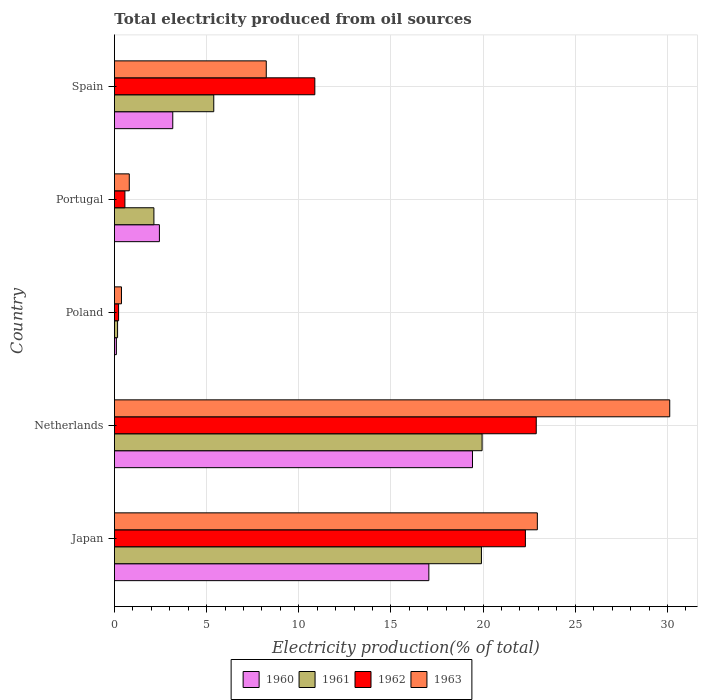How many groups of bars are there?
Your answer should be very brief. 5. Are the number of bars per tick equal to the number of legend labels?
Give a very brief answer. Yes. Are the number of bars on each tick of the Y-axis equal?
Offer a terse response. Yes. What is the label of the 3rd group of bars from the top?
Keep it short and to the point. Poland. In how many cases, is the number of bars for a given country not equal to the number of legend labels?
Your answer should be compact. 0. What is the total electricity produced in 1963 in Netherlands?
Your answer should be compact. 30.12. Across all countries, what is the maximum total electricity produced in 1962?
Offer a terse response. 22.88. Across all countries, what is the minimum total electricity produced in 1962?
Your answer should be very brief. 0.23. In which country was the total electricity produced in 1961 minimum?
Keep it short and to the point. Poland. What is the total total electricity produced in 1960 in the graph?
Your response must be concise. 42.19. What is the difference between the total electricity produced in 1963 in Japan and that in Portugal?
Keep it short and to the point. 22.14. What is the difference between the total electricity produced in 1962 in Japan and the total electricity produced in 1961 in Portugal?
Your response must be concise. 20.15. What is the average total electricity produced in 1961 per country?
Your answer should be very brief. 9.51. What is the difference between the total electricity produced in 1960 and total electricity produced in 1963 in Portugal?
Your response must be concise. 1.63. What is the ratio of the total electricity produced in 1960 in Netherlands to that in Spain?
Provide a succinct answer. 6.14. Is the total electricity produced in 1960 in Japan less than that in Poland?
Provide a succinct answer. No. What is the difference between the highest and the second highest total electricity produced in 1960?
Give a very brief answer. 2.37. What is the difference between the highest and the lowest total electricity produced in 1963?
Your answer should be compact. 29.74. Is the sum of the total electricity produced in 1962 in Japan and Netherlands greater than the maximum total electricity produced in 1963 across all countries?
Your answer should be compact. Yes. Is it the case that in every country, the sum of the total electricity produced in 1963 and total electricity produced in 1961 is greater than the sum of total electricity produced in 1960 and total electricity produced in 1962?
Your answer should be compact. No. What does the 2nd bar from the top in Poland represents?
Offer a terse response. 1962. What does the 2nd bar from the bottom in Portugal represents?
Offer a very short reply. 1961. Is it the case that in every country, the sum of the total electricity produced in 1961 and total electricity produced in 1962 is greater than the total electricity produced in 1960?
Your answer should be compact. Yes. How many bars are there?
Give a very brief answer. 20. Are all the bars in the graph horizontal?
Your answer should be very brief. Yes. How many countries are there in the graph?
Make the answer very short. 5. Are the values on the major ticks of X-axis written in scientific E-notation?
Offer a very short reply. No. Does the graph contain any zero values?
Make the answer very short. No. Does the graph contain grids?
Your response must be concise. Yes. Where does the legend appear in the graph?
Offer a terse response. Bottom center. What is the title of the graph?
Offer a terse response. Total electricity produced from oil sources. Does "1990" appear as one of the legend labels in the graph?
Keep it short and to the point. No. What is the Electricity production(% of total) of 1960 in Japan?
Ensure brevity in your answer.  17.06. What is the Electricity production(% of total) of 1961 in Japan?
Offer a very short reply. 19.91. What is the Electricity production(% of total) of 1962 in Japan?
Your response must be concise. 22.29. What is the Electricity production(% of total) in 1963 in Japan?
Give a very brief answer. 22.94. What is the Electricity production(% of total) in 1960 in Netherlands?
Your answer should be compact. 19.42. What is the Electricity production(% of total) of 1961 in Netherlands?
Give a very brief answer. 19.94. What is the Electricity production(% of total) of 1962 in Netherlands?
Offer a terse response. 22.88. What is the Electricity production(% of total) in 1963 in Netherlands?
Offer a terse response. 30.12. What is the Electricity production(% of total) in 1960 in Poland?
Your answer should be very brief. 0.11. What is the Electricity production(% of total) in 1961 in Poland?
Offer a terse response. 0.17. What is the Electricity production(% of total) of 1962 in Poland?
Give a very brief answer. 0.23. What is the Electricity production(% of total) of 1963 in Poland?
Offer a terse response. 0.38. What is the Electricity production(% of total) of 1960 in Portugal?
Your answer should be very brief. 2.44. What is the Electricity production(% of total) of 1961 in Portugal?
Offer a very short reply. 2.14. What is the Electricity production(% of total) of 1962 in Portugal?
Your response must be concise. 0.57. What is the Electricity production(% of total) in 1963 in Portugal?
Give a very brief answer. 0.81. What is the Electricity production(% of total) in 1960 in Spain?
Provide a succinct answer. 3.16. What is the Electricity production(% of total) in 1961 in Spain?
Make the answer very short. 5.39. What is the Electricity production(% of total) in 1962 in Spain?
Your answer should be compact. 10.87. What is the Electricity production(% of total) in 1963 in Spain?
Keep it short and to the point. 8.24. Across all countries, what is the maximum Electricity production(% of total) of 1960?
Provide a succinct answer. 19.42. Across all countries, what is the maximum Electricity production(% of total) in 1961?
Offer a terse response. 19.94. Across all countries, what is the maximum Electricity production(% of total) of 1962?
Your response must be concise. 22.88. Across all countries, what is the maximum Electricity production(% of total) of 1963?
Provide a succinct answer. 30.12. Across all countries, what is the minimum Electricity production(% of total) in 1960?
Make the answer very short. 0.11. Across all countries, what is the minimum Electricity production(% of total) in 1961?
Keep it short and to the point. 0.17. Across all countries, what is the minimum Electricity production(% of total) of 1962?
Give a very brief answer. 0.23. Across all countries, what is the minimum Electricity production(% of total) in 1963?
Make the answer very short. 0.38. What is the total Electricity production(% of total) of 1960 in the graph?
Your response must be concise. 42.19. What is the total Electricity production(% of total) of 1961 in the graph?
Make the answer very short. 47.55. What is the total Electricity production(% of total) of 1962 in the graph?
Provide a short and direct response. 56.84. What is the total Electricity production(% of total) of 1963 in the graph?
Make the answer very short. 62.49. What is the difference between the Electricity production(% of total) in 1960 in Japan and that in Netherlands?
Your answer should be very brief. -2.37. What is the difference between the Electricity production(% of total) of 1961 in Japan and that in Netherlands?
Your answer should be very brief. -0.04. What is the difference between the Electricity production(% of total) of 1962 in Japan and that in Netherlands?
Provide a short and direct response. -0.59. What is the difference between the Electricity production(% of total) in 1963 in Japan and that in Netherlands?
Your response must be concise. -7.18. What is the difference between the Electricity production(% of total) of 1960 in Japan and that in Poland?
Make the answer very short. 16.95. What is the difference between the Electricity production(% of total) in 1961 in Japan and that in Poland?
Ensure brevity in your answer.  19.74. What is the difference between the Electricity production(% of total) of 1962 in Japan and that in Poland?
Your answer should be very brief. 22.07. What is the difference between the Electricity production(% of total) in 1963 in Japan and that in Poland?
Your answer should be very brief. 22.56. What is the difference between the Electricity production(% of total) of 1960 in Japan and that in Portugal?
Your response must be concise. 14.62. What is the difference between the Electricity production(% of total) of 1961 in Japan and that in Portugal?
Your answer should be compact. 17.77. What is the difference between the Electricity production(% of total) of 1962 in Japan and that in Portugal?
Your answer should be very brief. 21.73. What is the difference between the Electricity production(% of total) of 1963 in Japan and that in Portugal?
Provide a succinct answer. 22.14. What is the difference between the Electricity production(% of total) in 1960 in Japan and that in Spain?
Keep it short and to the point. 13.89. What is the difference between the Electricity production(% of total) of 1961 in Japan and that in Spain?
Provide a short and direct response. 14.52. What is the difference between the Electricity production(% of total) of 1962 in Japan and that in Spain?
Make the answer very short. 11.42. What is the difference between the Electricity production(% of total) of 1963 in Japan and that in Spain?
Provide a succinct answer. 14.71. What is the difference between the Electricity production(% of total) of 1960 in Netherlands and that in Poland?
Ensure brevity in your answer.  19.32. What is the difference between the Electricity production(% of total) in 1961 in Netherlands and that in Poland?
Provide a succinct answer. 19.77. What is the difference between the Electricity production(% of total) in 1962 in Netherlands and that in Poland?
Keep it short and to the point. 22.66. What is the difference between the Electricity production(% of total) in 1963 in Netherlands and that in Poland?
Your response must be concise. 29.74. What is the difference between the Electricity production(% of total) of 1960 in Netherlands and that in Portugal?
Provide a succinct answer. 16.98. What is the difference between the Electricity production(% of total) in 1961 in Netherlands and that in Portugal?
Offer a very short reply. 17.8. What is the difference between the Electricity production(% of total) of 1962 in Netherlands and that in Portugal?
Offer a terse response. 22.31. What is the difference between the Electricity production(% of total) of 1963 in Netherlands and that in Portugal?
Provide a short and direct response. 29.32. What is the difference between the Electricity production(% of total) in 1960 in Netherlands and that in Spain?
Your answer should be compact. 16.26. What is the difference between the Electricity production(% of total) of 1961 in Netherlands and that in Spain?
Offer a terse response. 14.56. What is the difference between the Electricity production(% of total) in 1962 in Netherlands and that in Spain?
Make the answer very short. 12.01. What is the difference between the Electricity production(% of total) in 1963 in Netherlands and that in Spain?
Offer a very short reply. 21.89. What is the difference between the Electricity production(% of total) of 1960 in Poland and that in Portugal?
Your response must be concise. -2.33. What is the difference between the Electricity production(% of total) in 1961 in Poland and that in Portugal?
Your answer should be very brief. -1.97. What is the difference between the Electricity production(% of total) in 1962 in Poland and that in Portugal?
Provide a succinct answer. -0.34. What is the difference between the Electricity production(% of total) in 1963 in Poland and that in Portugal?
Give a very brief answer. -0.42. What is the difference between the Electricity production(% of total) in 1960 in Poland and that in Spain?
Provide a short and direct response. -3.06. What is the difference between the Electricity production(% of total) in 1961 in Poland and that in Spain?
Your answer should be very brief. -5.22. What is the difference between the Electricity production(% of total) of 1962 in Poland and that in Spain?
Your answer should be compact. -10.64. What is the difference between the Electricity production(% of total) of 1963 in Poland and that in Spain?
Give a very brief answer. -7.85. What is the difference between the Electricity production(% of total) in 1960 in Portugal and that in Spain?
Keep it short and to the point. -0.72. What is the difference between the Electricity production(% of total) in 1961 in Portugal and that in Spain?
Give a very brief answer. -3.25. What is the difference between the Electricity production(% of total) in 1962 in Portugal and that in Spain?
Your answer should be compact. -10.3. What is the difference between the Electricity production(% of total) in 1963 in Portugal and that in Spain?
Offer a terse response. -7.43. What is the difference between the Electricity production(% of total) in 1960 in Japan and the Electricity production(% of total) in 1961 in Netherlands?
Your answer should be very brief. -2.89. What is the difference between the Electricity production(% of total) in 1960 in Japan and the Electricity production(% of total) in 1962 in Netherlands?
Provide a succinct answer. -5.83. What is the difference between the Electricity production(% of total) of 1960 in Japan and the Electricity production(% of total) of 1963 in Netherlands?
Your answer should be very brief. -13.07. What is the difference between the Electricity production(% of total) of 1961 in Japan and the Electricity production(% of total) of 1962 in Netherlands?
Your response must be concise. -2.97. What is the difference between the Electricity production(% of total) of 1961 in Japan and the Electricity production(% of total) of 1963 in Netherlands?
Make the answer very short. -10.21. What is the difference between the Electricity production(% of total) of 1962 in Japan and the Electricity production(% of total) of 1963 in Netherlands?
Ensure brevity in your answer.  -7.83. What is the difference between the Electricity production(% of total) of 1960 in Japan and the Electricity production(% of total) of 1961 in Poland?
Provide a succinct answer. 16.89. What is the difference between the Electricity production(% of total) of 1960 in Japan and the Electricity production(% of total) of 1962 in Poland?
Offer a terse response. 16.83. What is the difference between the Electricity production(% of total) of 1960 in Japan and the Electricity production(% of total) of 1963 in Poland?
Ensure brevity in your answer.  16.67. What is the difference between the Electricity production(% of total) in 1961 in Japan and the Electricity production(% of total) in 1962 in Poland?
Make the answer very short. 19.68. What is the difference between the Electricity production(% of total) of 1961 in Japan and the Electricity production(% of total) of 1963 in Poland?
Offer a very short reply. 19.53. What is the difference between the Electricity production(% of total) of 1962 in Japan and the Electricity production(% of total) of 1963 in Poland?
Offer a terse response. 21.91. What is the difference between the Electricity production(% of total) of 1960 in Japan and the Electricity production(% of total) of 1961 in Portugal?
Offer a very short reply. 14.91. What is the difference between the Electricity production(% of total) in 1960 in Japan and the Electricity production(% of total) in 1962 in Portugal?
Offer a terse response. 16.49. What is the difference between the Electricity production(% of total) of 1960 in Japan and the Electricity production(% of total) of 1963 in Portugal?
Offer a very short reply. 16.25. What is the difference between the Electricity production(% of total) of 1961 in Japan and the Electricity production(% of total) of 1962 in Portugal?
Provide a short and direct response. 19.34. What is the difference between the Electricity production(% of total) in 1961 in Japan and the Electricity production(% of total) in 1963 in Portugal?
Give a very brief answer. 19.1. What is the difference between the Electricity production(% of total) of 1962 in Japan and the Electricity production(% of total) of 1963 in Portugal?
Provide a succinct answer. 21.49. What is the difference between the Electricity production(% of total) in 1960 in Japan and the Electricity production(% of total) in 1961 in Spain?
Provide a short and direct response. 11.67. What is the difference between the Electricity production(% of total) of 1960 in Japan and the Electricity production(% of total) of 1962 in Spain?
Your response must be concise. 6.19. What is the difference between the Electricity production(% of total) of 1960 in Japan and the Electricity production(% of total) of 1963 in Spain?
Keep it short and to the point. 8.82. What is the difference between the Electricity production(% of total) of 1961 in Japan and the Electricity production(% of total) of 1962 in Spain?
Make the answer very short. 9.04. What is the difference between the Electricity production(% of total) of 1961 in Japan and the Electricity production(% of total) of 1963 in Spain?
Give a very brief answer. 11.67. What is the difference between the Electricity production(% of total) of 1962 in Japan and the Electricity production(% of total) of 1963 in Spain?
Ensure brevity in your answer.  14.06. What is the difference between the Electricity production(% of total) in 1960 in Netherlands and the Electricity production(% of total) in 1961 in Poland?
Offer a very short reply. 19.25. What is the difference between the Electricity production(% of total) of 1960 in Netherlands and the Electricity production(% of total) of 1962 in Poland?
Ensure brevity in your answer.  19.2. What is the difference between the Electricity production(% of total) in 1960 in Netherlands and the Electricity production(% of total) in 1963 in Poland?
Provide a succinct answer. 19.04. What is the difference between the Electricity production(% of total) in 1961 in Netherlands and the Electricity production(% of total) in 1962 in Poland?
Provide a short and direct response. 19.72. What is the difference between the Electricity production(% of total) in 1961 in Netherlands and the Electricity production(% of total) in 1963 in Poland?
Your answer should be compact. 19.56. What is the difference between the Electricity production(% of total) of 1962 in Netherlands and the Electricity production(% of total) of 1963 in Poland?
Make the answer very short. 22.5. What is the difference between the Electricity production(% of total) in 1960 in Netherlands and the Electricity production(% of total) in 1961 in Portugal?
Your answer should be very brief. 17.28. What is the difference between the Electricity production(% of total) in 1960 in Netherlands and the Electricity production(% of total) in 1962 in Portugal?
Offer a terse response. 18.86. What is the difference between the Electricity production(% of total) in 1960 in Netherlands and the Electricity production(% of total) in 1963 in Portugal?
Your response must be concise. 18.62. What is the difference between the Electricity production(% of total) of 1961 in Netherlands and the Electricity production(% of total) of 1962 in Portugal?
Offer a very short reply. 19.38. What is the difference between the Electricity production(% of total) in 1961 in Netherlands and the Electricity production(% of total) in 1963 in Portugal?
Your answer should be compact. 19.14. What is the difference between the Electricity production(% of total) of 1962 in Netherlands and the Electricity production(% of total) of 1963 in Portugal?
Offer a terse response. 22.08. What is the difference between the Electricity production(% of total) in 1960 in Netherlands and the Electricity production(% of total) in 1961 in Spain?
Your answer should be compact. 14.04. What is the difference between the Electricity production(% of total) of 1960 in Netherlands and the Electricity production(% of total) of 1962 in Spain?
Provide a succinct answer. 8.55. What is the difference between the Electricity production(% of total) in 1960 in Netherlands and the Electricity production(% of total) in 1963 in Spain?
Ensure brevity in your answer.  11.19. What is the difference between the Electricity production(% of total) of 1961 in Netherlands and the Electricity production(% of total) of 1962 in Spain?
Your response must be concise. 9.07. What is the difference between the Electricity production(% of total) of 1961 in Netherlands and the Electricity production(% of total) of 1963 in Spain?
Offer a very short reply. 11.71. What is the difference between the Electricity production(% of total) of 1962 in Netherlands and the Electricity production(% of total) of 1963 in Spain?
Give a very brief answer. 14.65. What is the difference between the Electricity production(% of total) of 1960 in Poland and the Electricity production(% of total) of 1961 in Portugal?
Ensure brevity in your answer.  -2.04. What is the difference between the Electricity production(% of total) of 1960 in Poland and the Electricity production(% of total) of 1962 in Portugal?
Provide a succinct answer. -0.46. What is the difference between the Electricity production(% of total) of 1960 in Poland and the Electricity production(% of total) of 1963 in Portugal?
Your answer should be very brief. -0.7. What is the difference between the Electricity production(% of total) in 1961 in Poland and the Electricity production(% of total) in 1962 in Portugal?
Ensure brevity in your answer.  -0.4. What is the difference between the Electricity production(% of total) in 1961 in Poland and the Electricity production(% of total) in 1963 in Portugal?
Your answer should be very brief. -0.63. What is the difference between the Electricity production(% of total) in 1962 in Poland and the Electricity production(% of total) in 1963 in Portugal?
Make the answer very short. -0.58. What is the difference between the Electricity production(% of total) in 1960 in Poland and the Electricity production(% of total) in 1961 in Spain?
Your response must be concise. -5.28. What is the difference between the Electricity production(% of total) of 1960 in Poland and the Electricity production(% of total) of 1962 in Spain?
Offer a terse response. -10.77. What is the difference between the Electricity production(% of total) in 1960 in Poland and the Electricity production(% of total) in 1963 in Spain?
Offer a terse response. -8.13. What is the difference between the Electricity production(% of total) in 1961 in Poland and the Electricity production(% of total) in 1962 in Spain?
Ensure brevity in your answer.  -10.7. What is the difference between the Electricity production(% of total) of 1961 in Poland and the Electricity production(% of total) of 1963 in Spain?
Provide a succinct answer. -8.07. What is the difference between the Electricity production(% of total) of 1962 in Poland and the Electricity production(% of total) of 1963 in Spain?
Provide a short and direct response. -8.01. What is the difference between the Electricity production(% of total) of 1960 in Portugal and the Electricity production(% of total) of 1961 in Spain?
Make the answer very short. -2.95. What is the difference between the Electricity production(% of total) of 1960 in Portugal and the Electricity production(% of total) of 1962 in Spain?
Your answer should be very brief. -8.43. What is the difference between the Electricity production(% of total) in 1960 in Portugal and the Electricity production(% of total) in 1963 in Spain?
Your answer should be very brief. -5.8. What is the difference between the Electricity production(% of total) of 1961 in Portugal and the Electricity production(% of total) of 1962 in Spain?
Your response must be concise. -8.73. What is the difference between the Electricity production(% of total) in 1961 in Portugal and the Electricity production(% of total) in 1963 in Spain?
Offer a very short reply. -6.09. What is the difference between the Electricity production(% of total) of 1962 in Portugal and the Electricity production(% of total) of 1963 in Spain?
Offer a very short reply. -7.67. What is the average Electricity production(% of total) in 1960 per country?
Your answer should be compact. 8.44. What is the average Electricity production(% of total) in 1961 per country?
Ensure brevity in your answer.  9.51. What is the average Electricity production(% of total) of 1962 per country?
Provide a short and direct response. 11.37. What is the average Electricity production(% of total) in 1963 per country?
Offer a very short reply. 12.5. What is the difference between the Electricity production(% of total) in 1960 and Electricity production(% of total) in 1961 in Japan?
Make the answer very short. -2.85. What is the difference between the Electricity production(% of total) in 1960 and Electricity production(% of total) in 1962 in Japan?
Make the answer very short. -5.24. What is the difference between the Electricity production(% of total) in 1960 and Electricity production(% of total) in 1963 in Japan?
Ensure brevity in your answer.  -5.89. What is the difference between the Electricity production(% of total) in 1961 and Electricity production(% of total) in 1962 in Japan?
Your response must be concise. -2.38. What is the difference between the Electricity production(% of total) in 1961 and Electricity production(% of total) in 1963 in Japan?
Your answer should be compact. -3.03. What is the difference between the Electricity production(% of total) of 1962 and Electricity production(% of total) of 1963 in Japan?
Keep it short and to the point. -0.65. What is the difference between the Electricity production(% of total) of 1960 and Electricity production(% of total) of 1961 in Netherlands?
Offer a very short reply. -0.52. What is the difference between the Electricity production(% of total) in 1960 and Electricity production(% of total) in 1962 in Netherlands?
Make the answer very short. -3.46. What is the difference between the Electricity production(% of total) in 1960 and Electricity production(% of total) in 1963 in Netherlands?
Your answer should be compact. -10.7. What is the difference between the Electricity production(% of total) in 1961 and Electricity production(% of total) in 1962 in Netherlands?
Give a very brief answer. -2.94. What is the difference between the Electricity production(% of total) in 1961 and Electricity production(% of total) in 1963 in Netherlands?
Ensure brevity in your answer.  -10.18. What is the difference between the Electricity production(% of total) of 1962 and Electricity production(% of total) of 1963 in Netherlands?
Provide a succinct answer. -7.24. What is the difference between the Electricity production(% of total) in 1960 and Electricity production(% of total) in 1961 in Poland?
Your answer should be very brief. -0.06. What is the difference between the Electricity production(% of total) of 1960 and Electricity production(% of total) of 1962 in Poland?
Provide a succinct answer. -0.12. What is the difference between the Electricity production(% of total) in 1960 and Electricity production(% of total) in 1963 in Poland?
Your answer should be compact. -0.28. What is the difference between the Electricity production(% of total) in 1961 and Electricity production(% of total) in 1962 in Poland?
Your answer should be compact. -0.06. What is the difference between the Electricity production(% of total) in 1961 and Electricity production(% of total) in 1963 in Poland?
Offer a terse response. -0.21. What is the difference between the Electricity production(% of total) in 1962 and Electricity production(% of total) in 1963 in Poland?
Offer a very short reply. -0.16. What is the difference between the Electricity production(% of total) in 1960 and Electricity production(% of total) in 1961 in Portugal?
Your answer should be very brief. 0.3. What is the difference between the Electricity production(% of total) in 1960 and Electricity production(% of total) in 1962 in Portugal?
Keep it short and to the point. 1.87. What is the difference between the Electricity production(% of total) of 1960 and Electricity production(% of total) of 1963 in Portugal?
Offer a terse response. 1.63. What is the difference between the Electricity production(% of total) of 1961 and Electricity production(% of total) of 1962 in Portugal?
Your answer should be very brief. 1.57. What is the difference between the Electricity production(% of total) of 1961 and Electricity production(% of total) of 1963 in Portugal?
Offer a terse response. 1.34. What is the difference between the Electricity production(% of total) of 1962 and Electricity production(% of total) of 1963 in Portugal?
Your answer should be compact. -0.24. What is the difference between the Electricity production(% of total) of 1960 and Electricity production(% of total) of 1961 in Spain?
Make the answer very short. -2.22. What is the difference between the Electricity production(% of total) in 1960 and Electricity production(% of total) in 1962 in Spain?
Ensure brevity in your answer.  -7.71. What is the difference between the Electricity production(% of total) in 1960 and Electricity production(% of total) in 1963 in Spain?
Give a very brief answer. -5.07. What is the difference between the Electricity production(% of total) in 1961 and Electricity production(% of total) in 1962 in Spain?
Your response must be concise. -5.48. What is the difference between the Electricity production(% of total) of 1961 and Electricity production(% of total) of 1963 in Spain?
Provide a succinct answer. -2.85. What is the difference between the Electricity production(% of total) in 1962 and Electricity production(% of total) in 1963 in Spain?
Make the answer very short. 2.63. What is the ratio of the Electricity production(% of total) in 1960 in Japan to that in Netherlands?
Your response must be concise. 0.88. What is the ratio of the Electricity production(% of total) of 1962 in Japan to that in Netherlands?
Ensure brevity in your answer.  0.97. What is the ratio of the Electricity production(% of total) in 1963 in Japan to that in Netherlands?
Provide a short and direct response. 0.76. What is the ratio of the Electricity production(% of total) of 1960 in Japan to that in Poland?
Provide a short and direct response. 161.11. What is the ratio of the Electricity production(% of total) in 1961 in Japan to that in Poland?
Your answer should be compact. 116.7. What is the ratio of the Electricity production(% of total) of 1962 in Japan to that in Poland?
Offer a very short reply. 98.55. What is the ratio of the Electricity production(% of total) of 1963 in Japan to that in Poland?
Provide a succinct answer. 60.11. What is the ratio of the Electricity production(% of total) in 1960 in Japan to that in Portugal?
Provide a short and direct response. 6.99. What is the ratio of the Electricity production(% of total) in 1961 in Japan to that in Portugal?
Ensure brevity in your answer.  9.3. What is the ratio of the Electricity production(% of total) of 1962 in Japan to that in Portugal?
Your answer should be compact. 39.24. What is the ratio of the Electricity production(% of total) of 1963 in Japan to that in Portugal?
Provide a short and direct response. 28.49. What is the ratio of the Electricity production(% of total) in 1960 in Japan to that in Spain?
Ensure brevity in your answer.  5.39. What is the ratio of the Electricity production(% of total) in 1961 in Japan to that in Spain?
Your answer should be very brief. 3.69. What is the ratio of the Electricity production(% of total) in 1962 in Japan to that in Spain?
Your answer should be compact. 2.05. What is the ratio of the Electricity production(% of total) of 1963 in Japan to that in Spain?
Provide a succinct answer. 2.79. What is the ratio of the Electricity production(% of total) of 1960 in Netherlands to that in Poland?
Keep it short and to the point. 183.47. What is the ratio of the Electricity production(% of total) in 1961 in Netherlands to that in Poland?
Provide a short and direct response. 116.91. What is the ratio of the Electricity production(% of total) of 1962 in Netherlands to that in Poland?
Provide a succinct answer. 101.15. What is the ratio of the Electricity production(% of total) of 1963 in Netherlands to that in Poland?
Provide a short and direct response. 78.92. What is the ratio of the Electricity production(% of total) in 1960 in Netherlands to that in Portugal?
Ensure brevity in your answer.  7.96. What is the ratio of the Electricity production(% of total) in 1961 in Netherlands to that in Portugal?
Ensure brevity in your answer.  9.31. What is the ratio of the Electricity production(% of total) of 1962 in Netherlands to that in Portugal?
Provide a short and direct response. 40.27. What is the ratio of the Electricity production(% of total) in 1963 in Netherlands to that in Portugal?
Make the answer very short. 37.4. What is the ratio of the Electricity production(% of total) of 1960 in Netherlands to that in Spain?
Offer a very short reply. 6.14. What is the ratio of the Electricity production(% of total) in 1961 in Netherlands to that in Spain?
Your response must be concise. 3.7. What is the ratio of the Electricity production(% of total) in 1962 in Netherlands to that in Spain?
Ensure brevity in your answer.  2.1. What is the ratio of the Electricity production(% of total) in 1963 in Netherlands to that in Spain?
Make the answer very short. 3.66. What is the ratio of the Electricity production(% of total) in 1960 in Poland to that in Portugal?
Make the answer very short. 0.04. What is the ratio of the Electricity production(% of total) in 1961 in Poland to that in Portugal?
Your response must be concise. 0.08. What is the ratio of the Electricity production(% of total) of 1962 in Poland to that in Portugal?
Your response must be concise. 0.4. What is the ratio of the Electricity production(% of total) of 1963 in Poland to that in Portugal?
Your answer should be compact. 0.47. What is the ratio of the Electricity production(% of total) in 1960 in Poland to that in Spain?
Your answer should be compact. 0.03. What is the ratio of the Electricity production(% of total) in 1961 in Poland to that in Spain?
Keep it short and to the point. 0.03. What is the ratio of the Electricity production(% of total) in 1962 in Poland to that in Spain?
Keep it short and to the point. 0.02. What is the ratio of the Electricity production(% of total) in 1963 in Poland to that in Spain?
Make the answer very short. 0.05. What is the ratio of the Electricity production(% of total) in 1960 in Portugal to that in Spain?
Your answer should be compact. 0.77. What is the ratio of the Electricity production(% of total) in 1961 in Portugal to that in Spain?
Your answer should be very brief. 0.4. What is the ratio of the Electricity production(% of total) in 1962 in Portugal to that in Spain?
Offer a terse response. 0.05. What is the ratio of the Electricity production(% of total) in 1963 in Portugal to that in Spain?
Your response must be concise. 0.1. What is the difference between the highest and the second highest Electricity production(% of total) in 1960?
Provide a succinct answer. 2.37. What is the difference between the highest and the second highest Electricity production(% of total) of 1961?
Provide a short and direct response. 0.04. What is the difference between the highest and the second highest Electricity production(% of total) in 1962?
Provide a short and direct response. 0.59. What is the difference between the highest and the second highest Electricity production(% of total) in 1963?
Make the answer very short. 7.18. What is the difference between the highest and the lowest Electricity production(% of total) of 1960?
Your answer should be very brief. 19.32. What is the difference between the highest and the lowest Electricity production(% of total) in 1961?
Give a very brief answer. 19.77. What is the difference between the highest and the lowest Electricity production(% of total) of 1962?
Your answer should be very brief. 22.66. What is the difference between the highest and the lowest Electricity production(% of total) in 1963?
Provide a short and direct response. 29.74. 